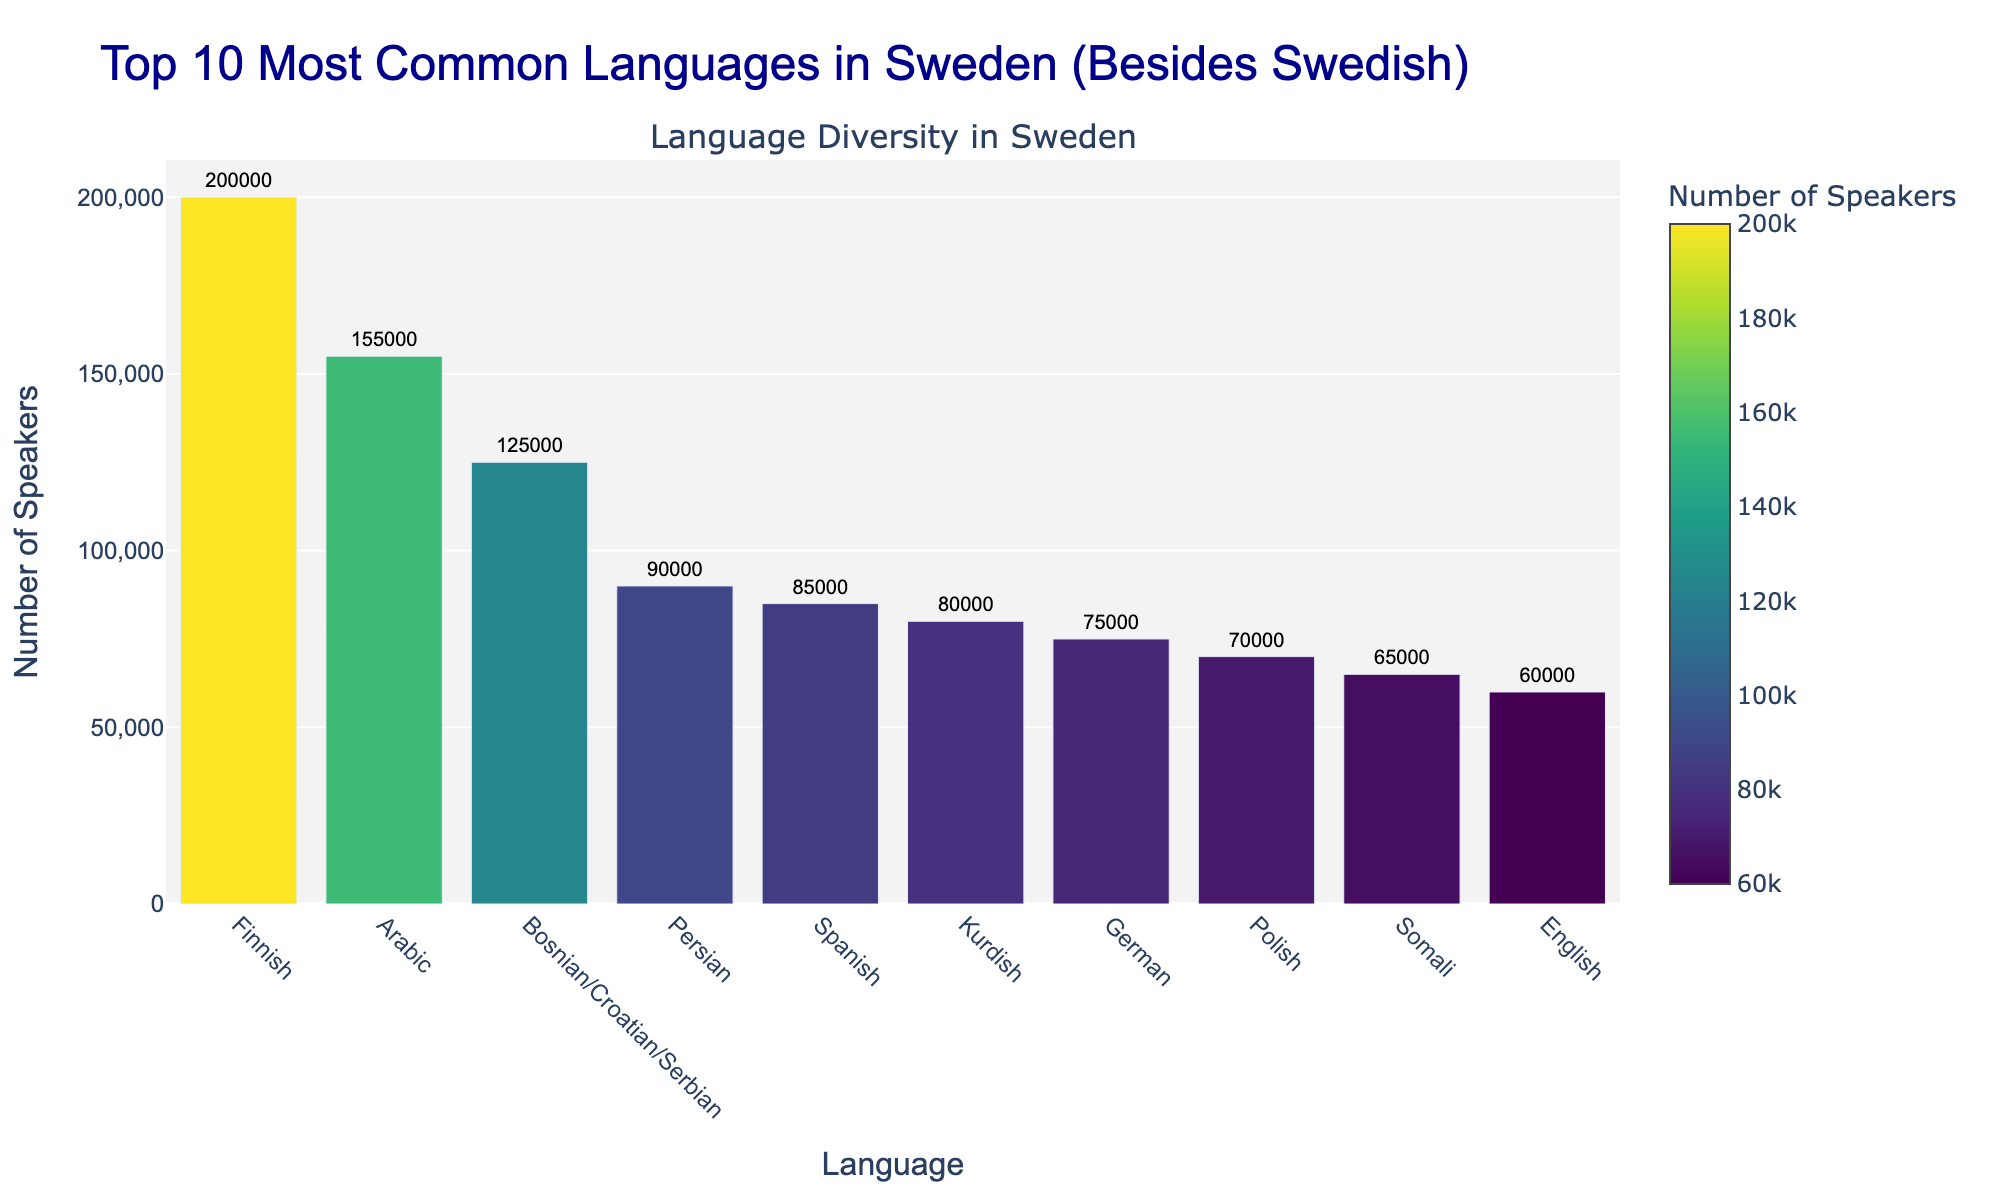What is the most common language in Sweden aside from Swedish? By looking at the bar chart, the tallest bar represents the most common language besides Swedish. This bar corresponds to Finnish, which has the most number of speakers.
Answer: Finnish How many more speakers does Finnish have compared to English? First, identify the number of speakers for Finnish (200,000) and English (60,000). Then, subtract the number of English speakers from the number of Finnish speakers: 200,000 - 60,000 = 140,000.
Answer: 140,000 Which language has fewer speakers: German or Persian? Compare the heights of the bars for German and Persian. The number of German speakers is 75,000, while the number of Persian speakers is 90,000. Hence, German has fewer speakers than Persian.
Answer: German What is the difference in the number of speakers between the third and the seventh most common languages? Identify the third most common language (Bosnian/Croatian/Serbian - 125,000 speakers) and the seventh most common language (German - 75,000 speakers). Subtract the number of German speakers from the number of Bosnian/Croatian/Serbian speakers: 125,000 - 75,000 = 50,000.
Answer: 50,000 Which languages have more than 100,000 speakers? Scan the bar chart for languages with bars extending beyond the 100,000 mark. These languages are Finnish (200,000), Arabic (155,000), and Bosnian/Croatian/Serbian (125,000).
Answer: Finnish, Arabic, Bosnian/Croatian/Serbian What is the total number of speakers for all the languages listed? Add up the number of speakers for each language: 200,000 (Finnish) + 155,000 (Arabic) + 125,000 (Bosnian/Croatian/Serbian) + 90,000 (Persian) + 85,000 (Spanish) + 80,000 (Kurdish) + 75,000 (German) + 70,000 (Polish) + 65,000 (Somali) + 60,000 (English) = 1,005,000.
Answer: 1,005,000 Which language has just slightly fewer speakers than Spanish? Look for the language that has a bar just below the bar for Spanish (85,000 speakers). The next shortest bar corresponds to Kurdish (80,000).
Answer: Kurdish What's the average number of speakers among the top 10 most common languages besides Swedish? Add the number of speakers for each of the ten languages and divide by 10: (200,000 + 155,000 + 125,000 + 90,000 + 85,000 + 80,000 + 75,000 + 70,000 + 65,000 + 60,000) / 10 = 100,500.
Answer: 100,500 